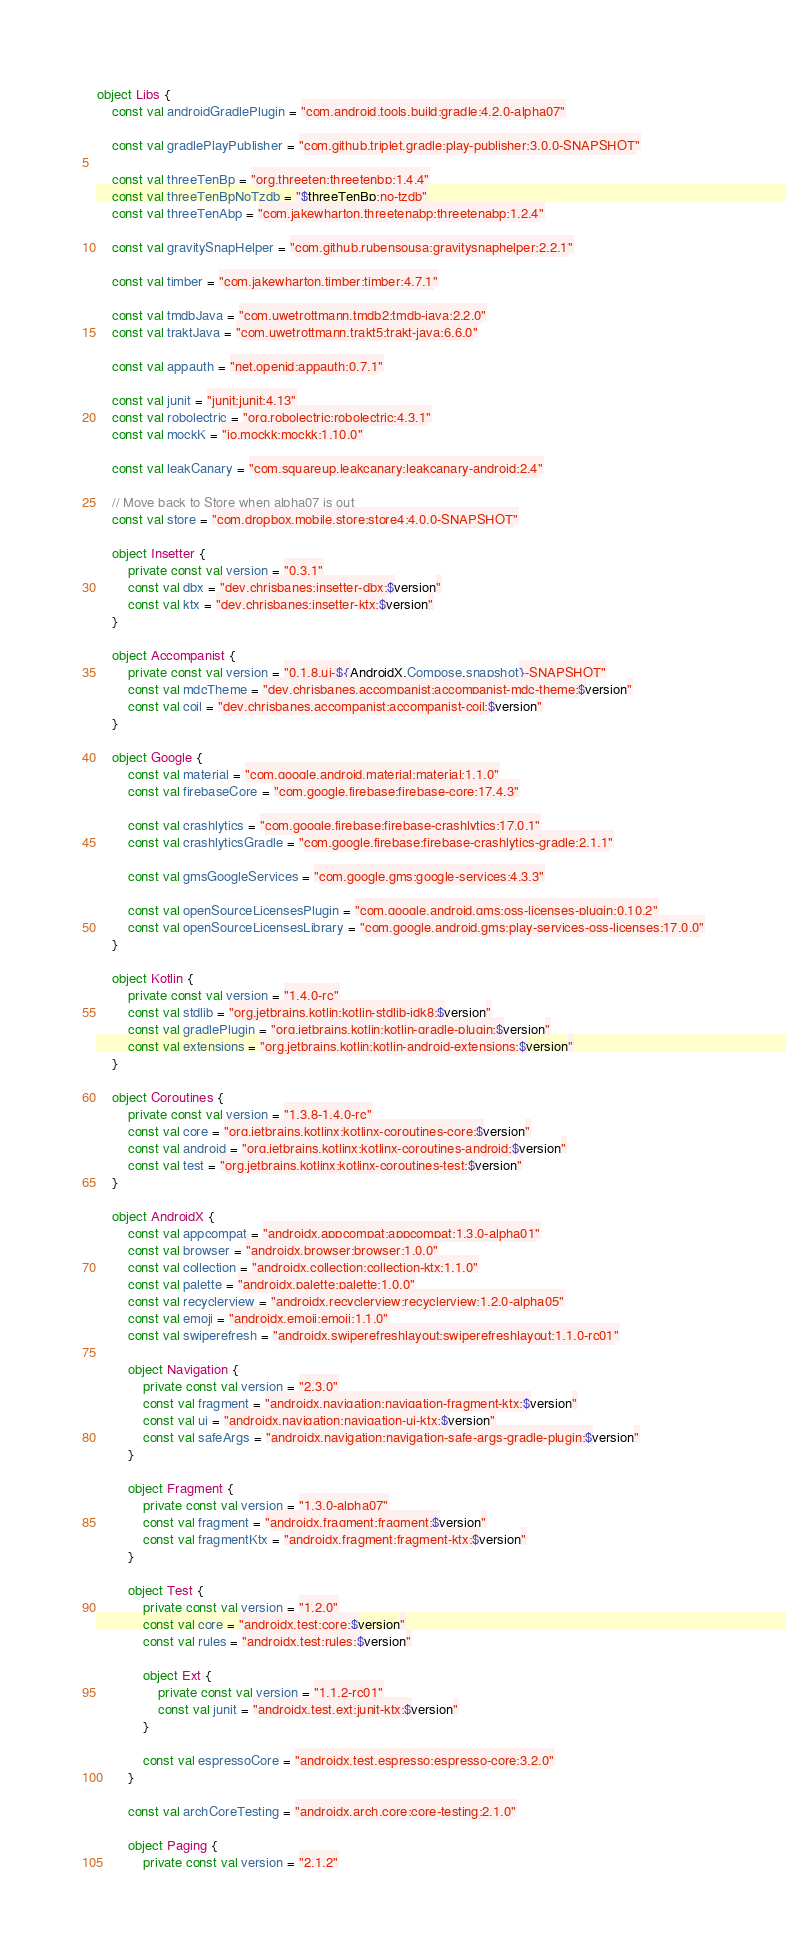<code> <loc_0><loc_0><loc_500><loc_500><_Kotlin_>object Libs {
    const val androidGradlePlugin = "com.android.tools.build:gradle:4.2.0-alpha07"

    const val gradlePlayPublisher = "com.github.triplet.gradle:play-publisher:3.0.0-SNAPSHOT"

    const val threeTenBp = "org.threeten:threetenbp:1.4.4"
    const val threeTenBpNoTzdb = "$threeTenBp:no-tzdb"
    const val threeTenAbp = "com.jakewharton.threetenabp:threetenabp:1.2.4"

    const val gravitySnapHelper = "com.github.rubensousa:gravitysnaphelper:2.2.1"

    const val timber = "com.jakewharton.timber:timber:4.7.1"

    const val tmdbJava = "com.uwetrottmann.tmdb2:tmdb-java:2.2.0"
    const val traktJava = "com.uwetrottmann.trakt5:trakt-java:6.6.0"

    const val appauth = "net.openid:appauth:0.7.1"

    const val junit = "junit:junit:4.13"
    const val robolectric = "org.robolectric:robolectric:4.3.1"
    const val mockK = "io.mockk:mockk:1.10.0"

    const val leakCanary = "com.squareup.leakcanary:leakcanary-android:2.4"

    // Move back to Store when alpha07 is out
    const val store = "com.dropbox.mobile.store:store4:4.0.0-SNAPSHOT"

    object Insetter {
        private const val version = "0.3.1"
        const val dbx = "dev.chrisbanes:insetter-dbx:$version"
        const val ktx = "dev.chrisbanes:insetter-ktx:$version"
    }

    object Accompanist {
        private const val version = "0.1.8.ui-${AndroidX.Compose.snapshot}-SNAPSHOT"
        const val mdcTheme = "dev.chrisbanes.accompanist:accompanist-mdc-theme:$version"
        const val coil = "dev.chrisbanes.accompanist:accompanist-coil:$version"
    }

    object Google {
        const val material = "com.google.android.material:material:1.1.0"
        const val firebaseCore = "com.google.firebase:firebase-core:17.4.3"

        const val crashlytics = "com.google.firebase:firebase-crashlytics:17.0.1"
        const val crashlyticsGradle = "com.google.firebase:firebase-crashlytics-gradle:2.1.1"

        const val gmsGoogleServices = "com.google.gms:google-services:4.3.3"

        const val openSourceLicensesPlugin = "com.google.android.gms:oss-licenses-plugin:0.10.2"
        const val openSourceLicensesLibrary = "com.google.android.gms:play-services-oss-licenses:17.0.0"
    }

    object Kotlin {
        private const val version = "1.4.0-rc"
        const val stdlib = "org.jetbrains.kotlin:kotlin-stdlib-jdk8:$version"
        const val gradlePlugin = "org.jetbrains.kotlin:kotlin-gradle-plugin:$version"
        const val extensions = "org.jetbrains.kotlin:kotlin-android-extensions:$version"
    }

    object Coroutines {
        private const val version = "1.3.8-1.4.0-rc"
        const val core = "org.jetbrains.kotlinx:kotlinx-coroutines-core:$version"
        const val android = "org.jetbrains.kotlinx:kotlinx-coroutines-android:$version"
        const val test = "org.jetbrains.kotlinx:kotlinx-coroutines-test:$version"
    }

    object AndroidX {
        const val appcompat = "androidx.appcompat:appcompat:1.3.0-alpha01"
        const val browser = "androidx.browser:browser:1.0.0"
        const val collection = "androidx.collection:collection-ktx:1.1.0"
        const val palette = "androidx.palette:palette:1.0.0"
        const val recyclerview = "androidx.recyclerview:recyclerview:1.2.0-alpha05"
        const val emoji = "androidx.emoji:emoji:1.1.0"
        const val swiperefresh = "androidx.swiperefreshlayout:swiperefreshlayout:1.1.0-rc01"

        object Navigation {
            private const val version = "2.3.0"
            const val fragment = "androidx.navigation:navigation-fragment-ktx:$version"
            const val ui = "androidx.navigation:navigation-ui-ktx:$version"
            const val safeArgs = "androidx.navigation:navigation-safe-args-gradle-plugin:$version"
        }

        object Fragment {
            private const val version = "1.3.0-alpha07"
            const val fragment = "androidx.fragment:fragment:$version"
            const val fragmentKtx = "androidx.fragment:fragment-ktx:$version"
        }

        object Test {
            private const val version = "1.2.0"
            const val core = "androidx.test:core:$version"
            const val rules = "androidx.test:rules:$version"

            object Ext {
                private const val version = "1.1.2-rc01"
                const val junit = "androidx.test.ext:junit-ktx:$version"
            }

            const val espressoCore = "androidx.test.espresso:espresso-core:3.2.0"
        }

        const val archCoreTesting = "androidx.arch.core:core-testing:2.1.0"

        object Paging {
            private const val version = "2.1.2"</code> 